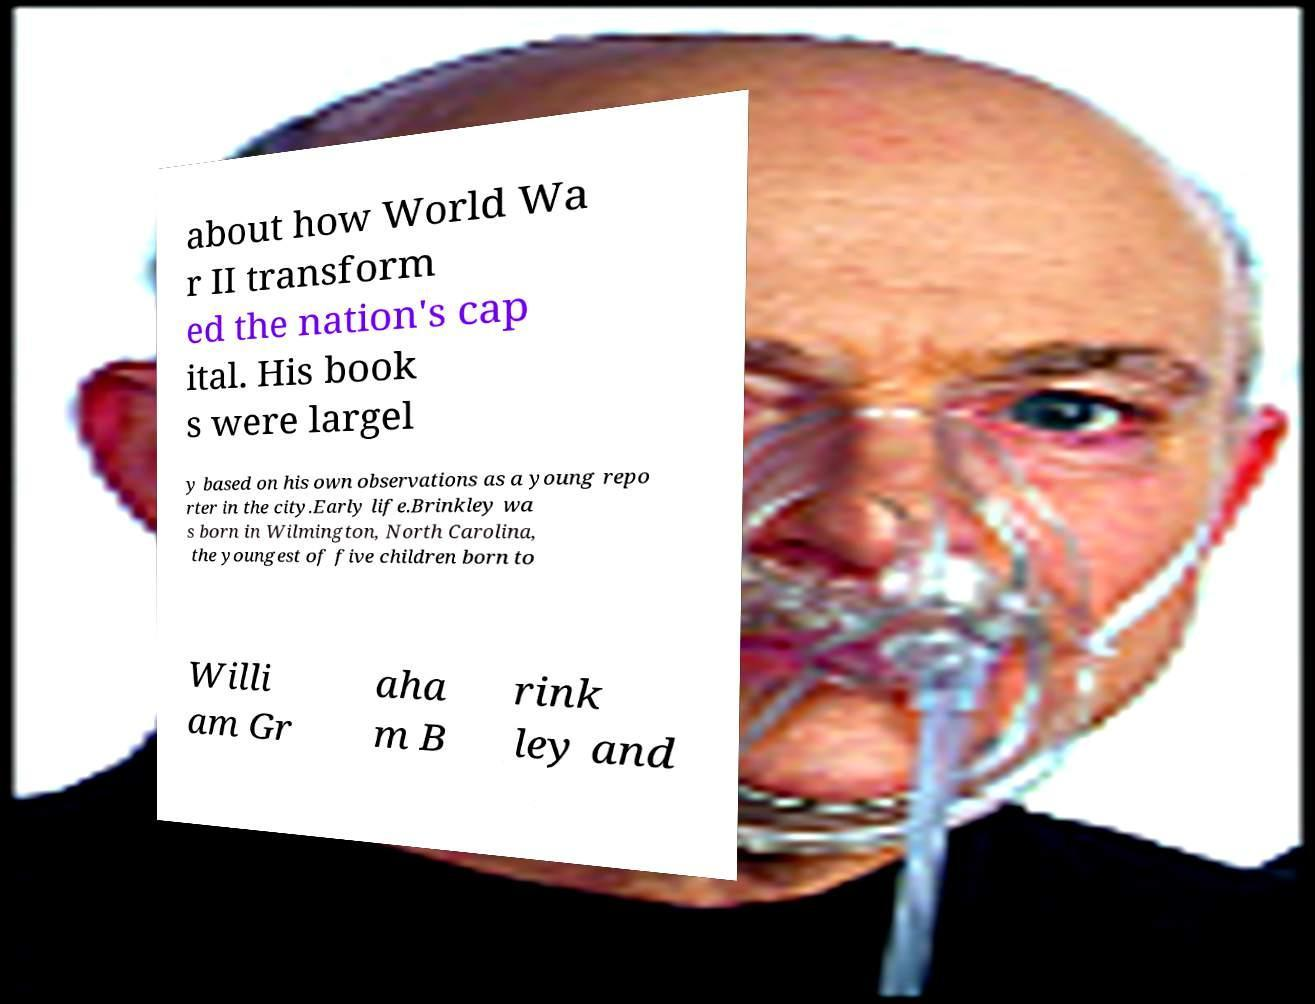There's text embedded in this image that I need extracted. Can you transcribe it verbatim? about how World Wa r II transform ed the nation's cap ital. His book s were largel y based on his own observations as a young repo rter in the city.Early life.Brinkley wa s born in Wilmington, North Carolina, the youngest of five children born to Willi am Gr aha m B rink ley and 